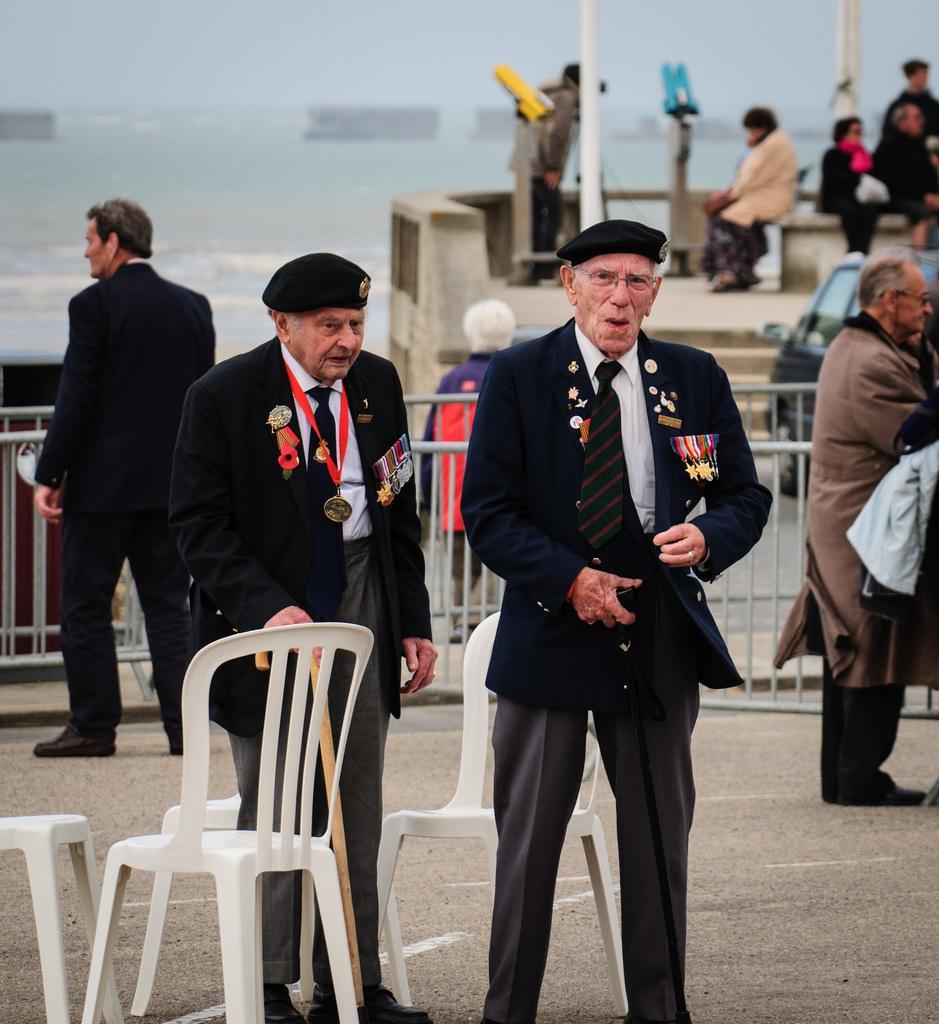Could you give a brief overview of what you see in this image? This image is clicked outside. There are chairs in this image, there is an iron railing in the middle. There are so many people in this image who are standing. There is a car on the right side. There is water on the left side. There are two person standing in the middle. 